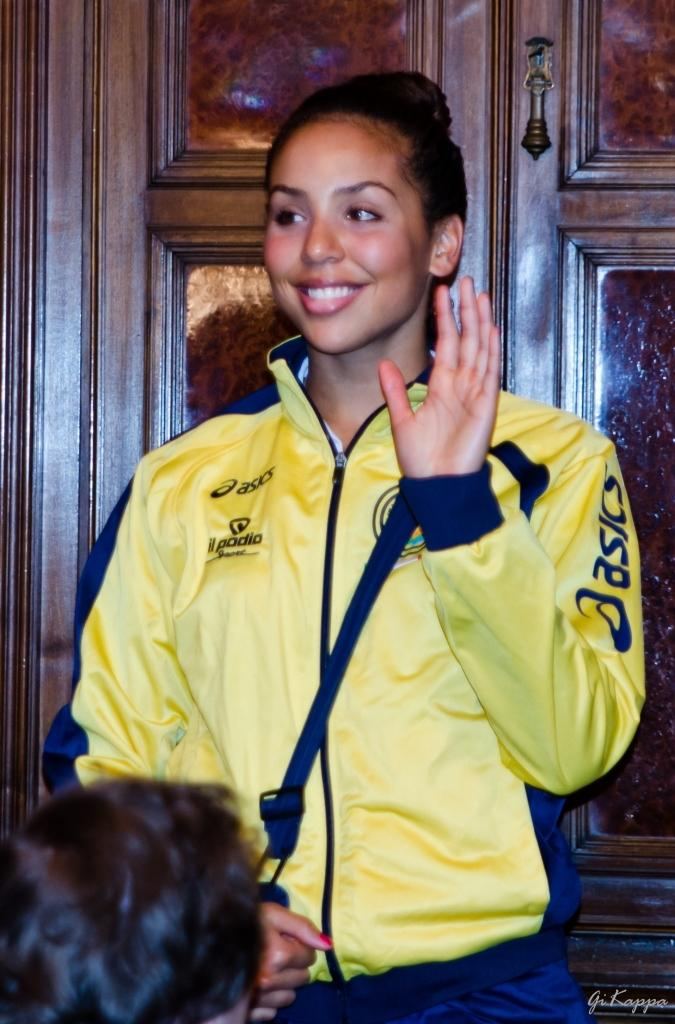Provide a one-sentence caption for the provided image. a girl waving with a yellow jacket from asics. 